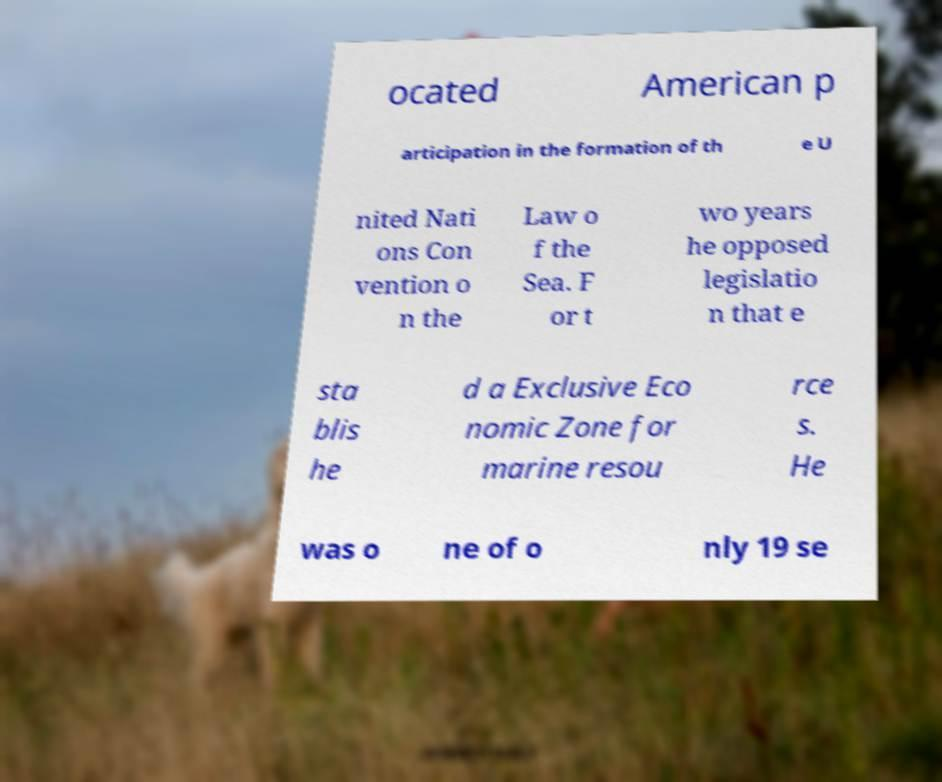Can you accurately transcribe the text from the provided image for me? ocated American p articipation in the formation of th e U nited Nati ons Con vention o n the Law o f the Sea. F or t wo years he opposed legislatio n that e sta blis he d a Exclusive Eco nomic Zone for marine resou rce s. He was o ne of o nly 19 se 